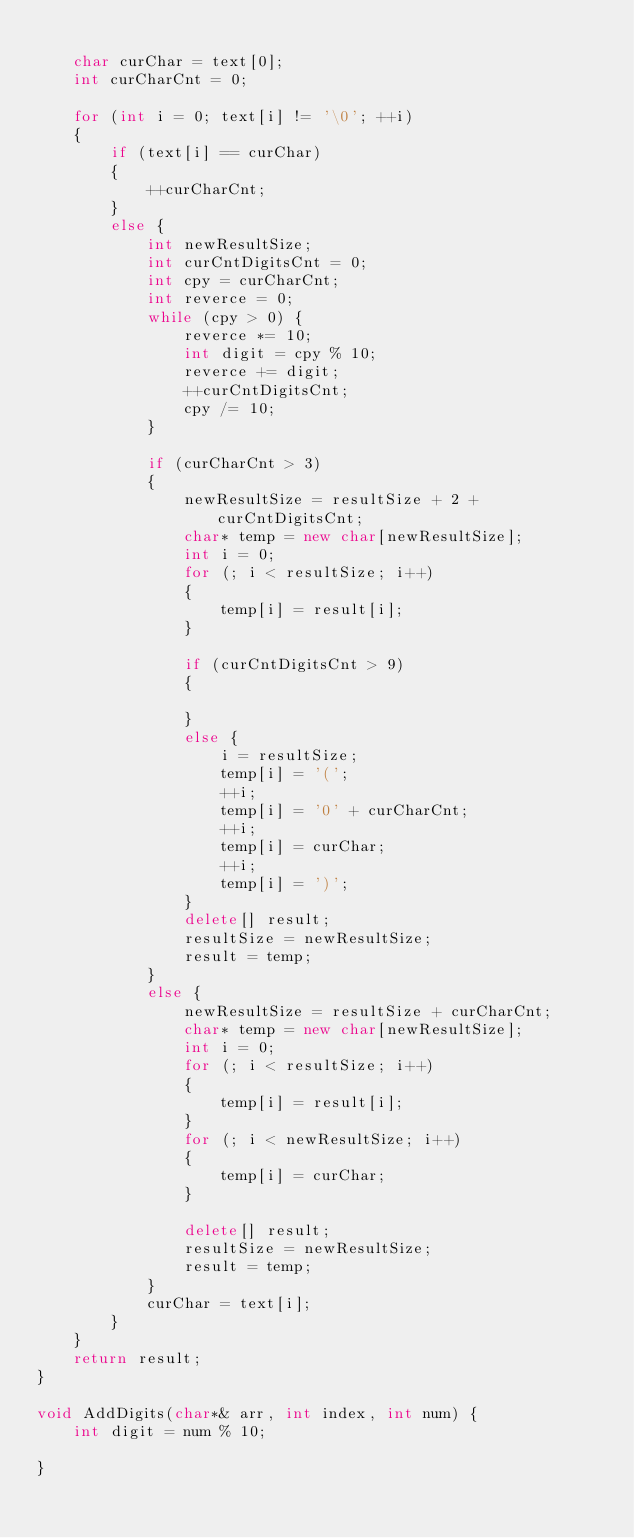<code> <loc_0><loc_0><loc_500><loc_500><_C++_>
	char curChar = text[0];
	int curCharCnt = 0;

	for (int i = 0; text[i] != '\0'; ++i)
	{
		if (text[i] == curChar)
		{
			++curCharCnt;
		}
		else {
			int newResultSize;
			int curCntDigitsCnt = 0;
			int cpy = curCharCnt;
			int reverce = 0;
			while (cpy > 0) {
				reverce *= 10;
				int digit = cpy % 10;
				reverce += digit;
				++curCntDigitsCnt;
				cpy /= 10;
			}

			if (curCharCnt > 3)
			{
				newResultSize = resultSize + 2 + curCntDigitsCnt;
				char* temp = new char[newResultSize];
				int i = 0;
				for (; i < resultSize; i++)
				{
					temp[i] = result[i];
				}

				if (curCntDigitsCnt > 9)
				{
					
				}
				else {
					i = resultSize;
					temp[i] = '(';
					++i;
					temp[i] = '0' + curCharCnt;
					++i;
					temp[i] = curChar;
					++i;
					temp[i] = ')';
				}
				delete[] result;
				resultSize = newResultSize;
				result = temp;
			}
			else {
				newResultSize = resultSize + curCharCnt;
				char* temp = new char[newResultSize];
				int i = 0;
				for (; i < resultSize; i++)
				{
					temp[i] = result[i];
				}
				for (; i < newResultSize; i++)
				{
					temp[i] = curChar;
				}

				delete[] result;
				resultSize = newResultSize;
				result = temp;
			}
			curChar = text[i];
		}
	}
	return result;
}

void AddDigits(char*& arr, int index, int num) {
	int digit = num % 10;

}
</code> 